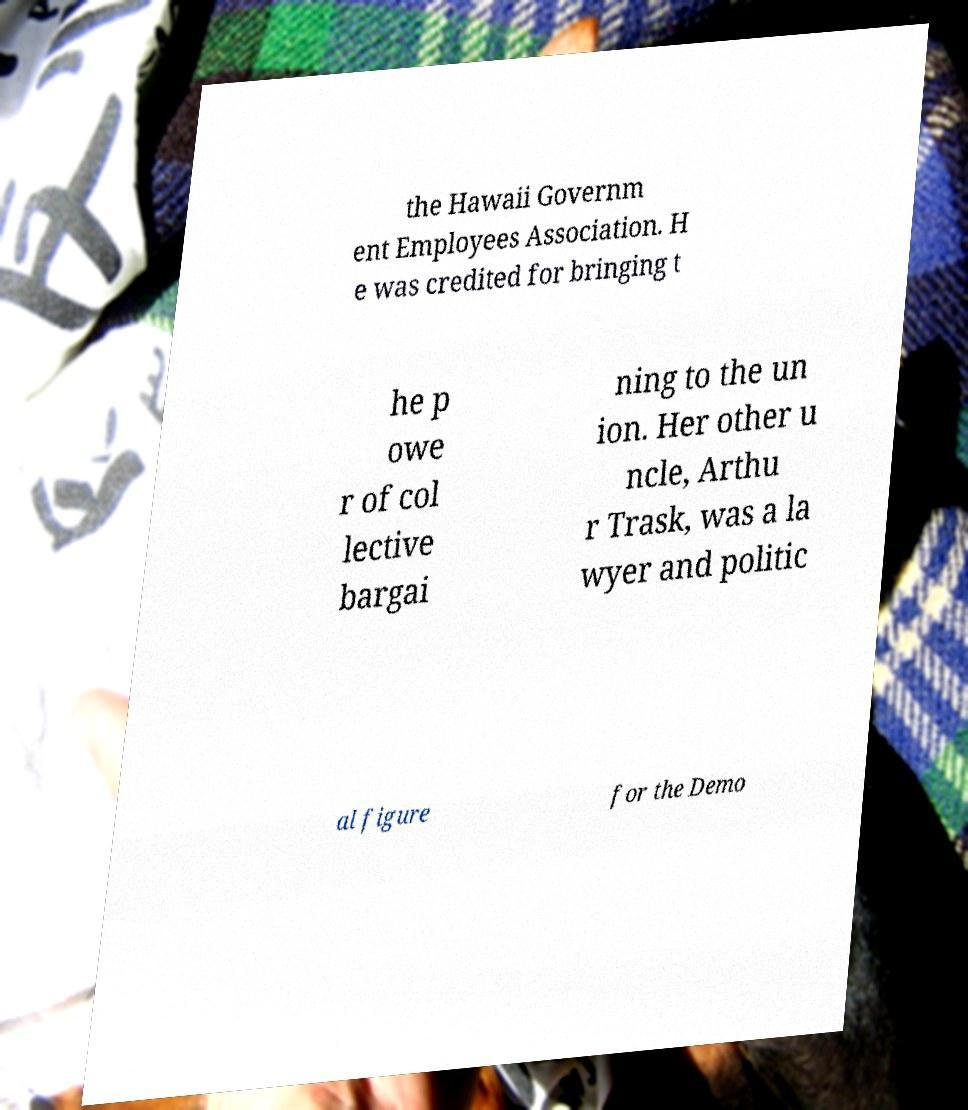Can you accurately transcribe the text from the provided image for me? the Hawaii Governm ent Employees Association. H e was credited for bringing t he p owe r of col lective bargai ning to the un ion. Her other u ncle, Arthu r Trask, was a la wyer and politic al figure for the Demo 